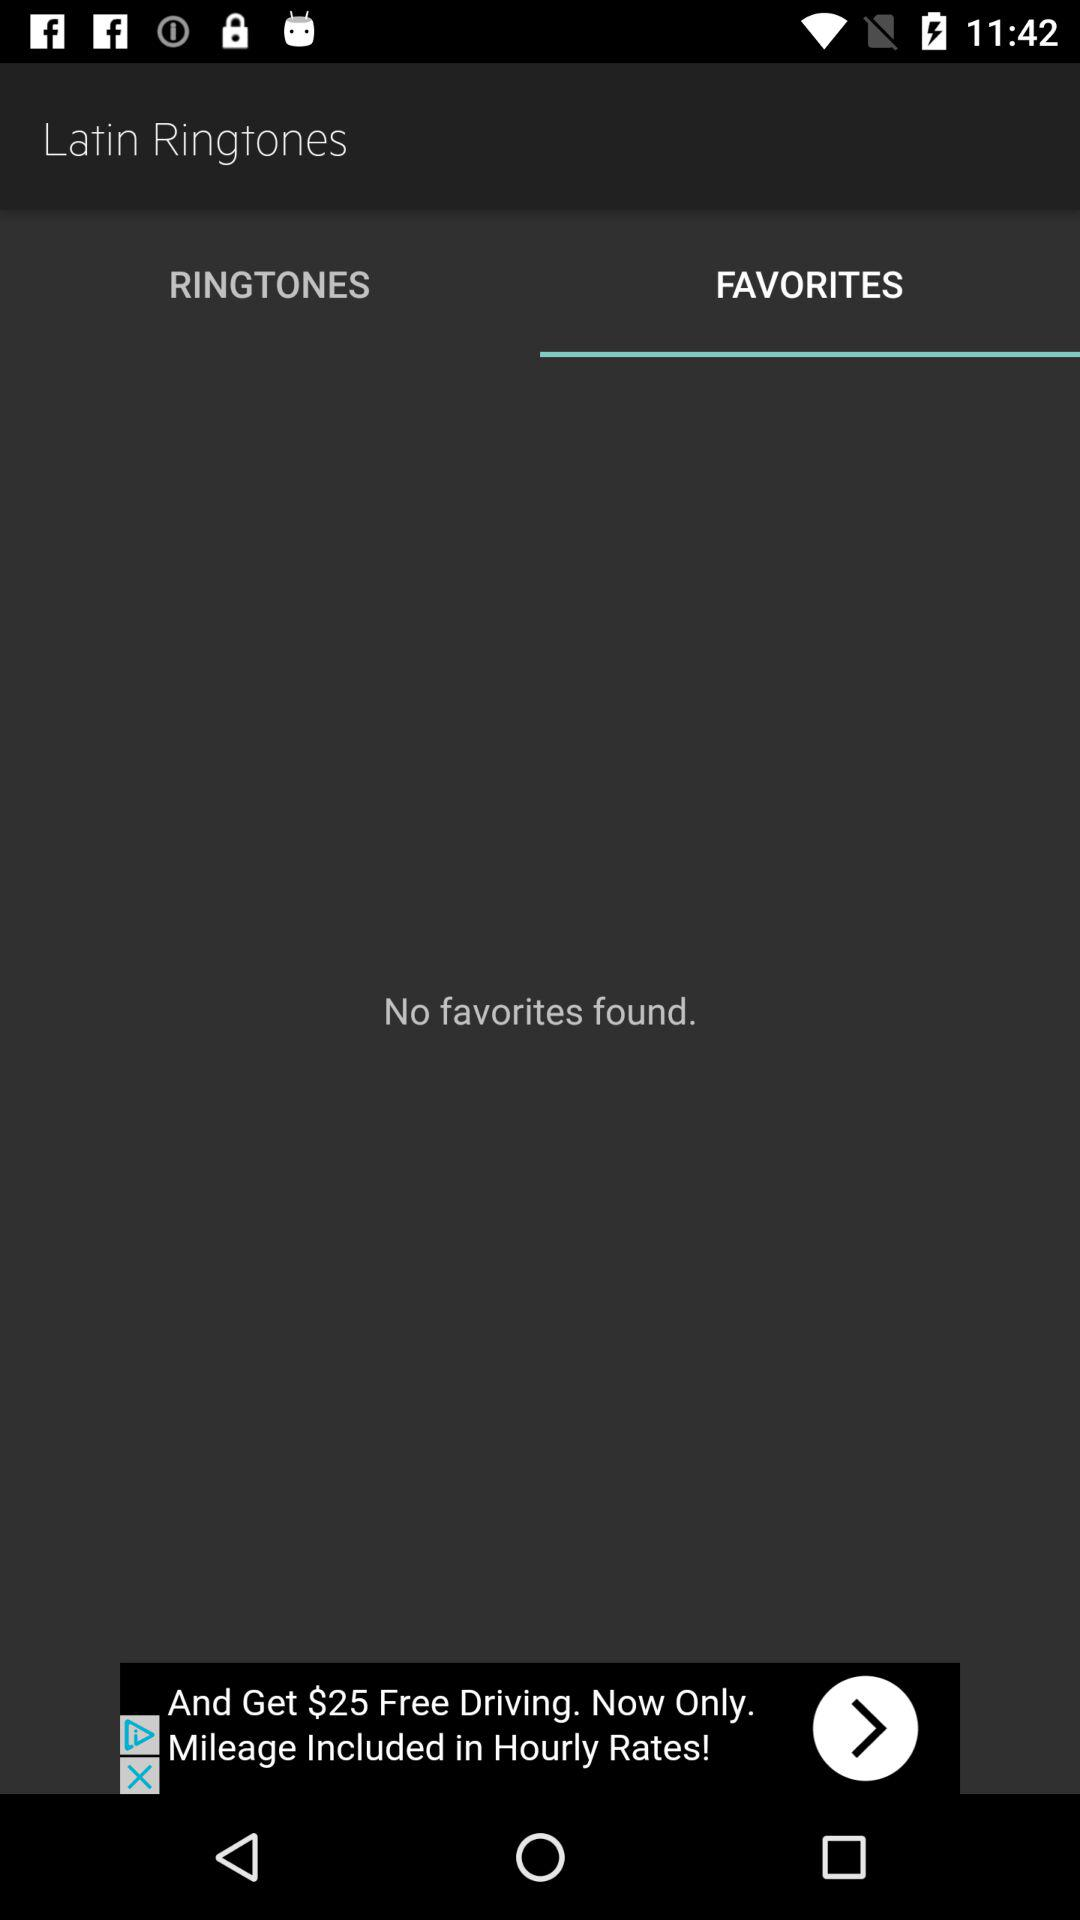How many items are in "RINGTONES"?
When the provided information is insufficient, respond with <no answer>. <no answer> 